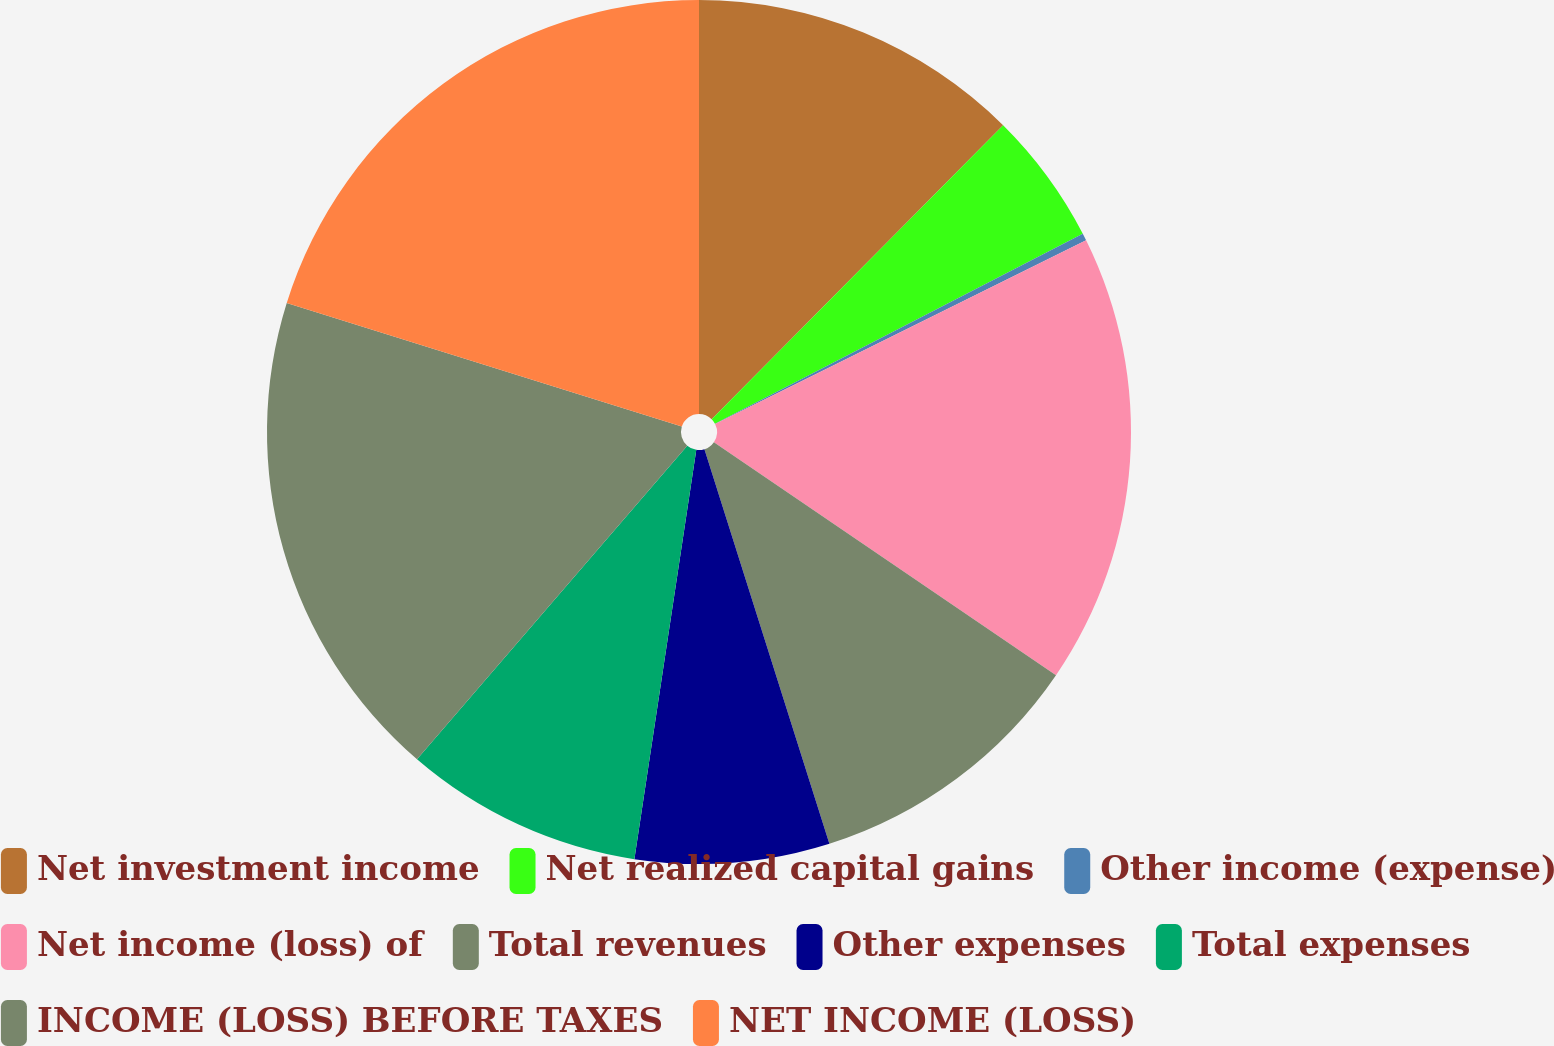<chart> <loc_0><loc_0><loc_500><loc_500><pie_chart><fcel>Net investment income<fcel>Net realized capital gains<fcel>Other income (expense)<fcel>Net income (loss) of<fcel>Total revenues<fcel>Other expenses<fcel>Total expenses<fcel>INCOME (LOSS) BEFORE TAXES<fcel>NET INCOME (LOSS)<nl><fcel>12.43%<fcel>4.98%<fcel>0.27%<fcel>16.84%<fcel>10.6%<fcel>7.27%<fcel>8.93%<fcel>18.51%<fcel>20.17%<nl></chart> 